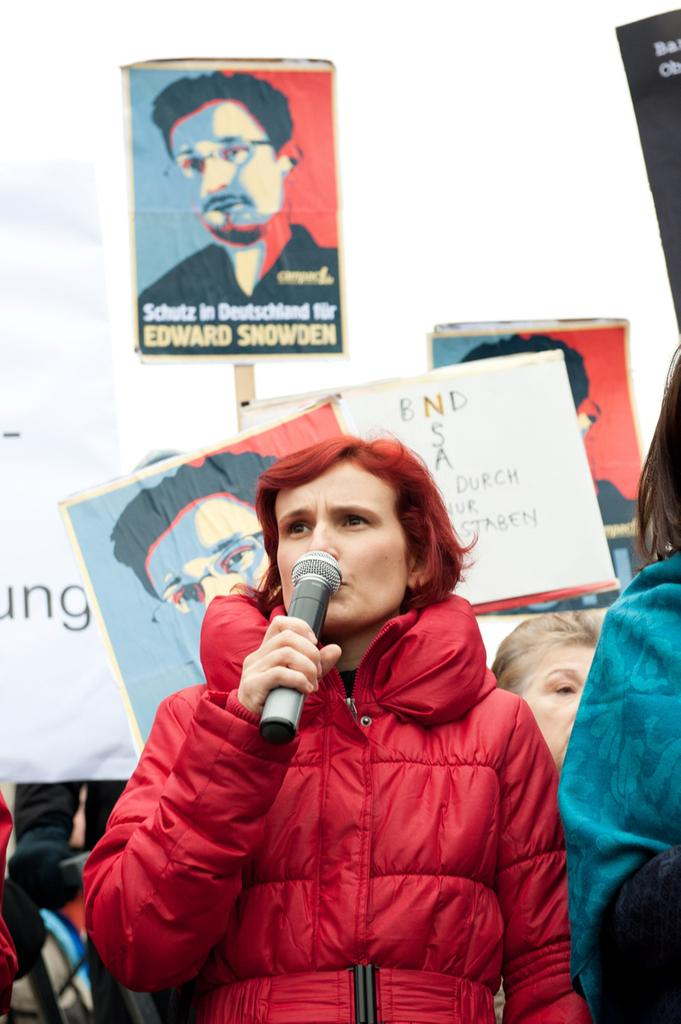Who is the main subject in the image? There is a lady person in the image. What is the lady person wearing? The lady person is wearing a red color raincoat. What is the lady person holding in the image? The lady person is holding a microphone. What other types of boards can be seen in the image besides the microphone? There are quotation boards and name boards in the image. Can you tell me how many doctors are present in the image? There are no doctors present in the image. Is the lady person jumping in the image? There is no indication that the lady person is jumping in the image. 